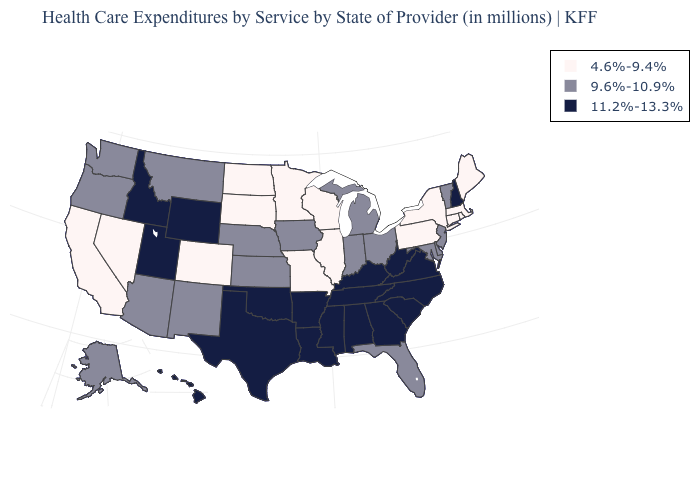Does West Virginia have the lowest value in the USA?
Be succinct. No. What is the value of Michigan?
Give a very brief answer. 9.6%-10.9%. Name the states that have a value in the range 4.6%-9.4%?
Keep it brief. California, Colorado, Connecticut, Illinois, Maine, Massachusetts, Minnesota, Missouri, Nevada, New York, North Dakota, Pennsylvania, Rhode Island, South Dakota, Wisconsin. Does Wyoming have the same value as South Carolina?
Answer briefly. Yes. Which states have the highest value in the USA?
Be succinct. Alabama, Arkansas, Georgia, Hawaii, Idaho, Kentucky, Louisiana, Mississippi, New Hampshire, North Carolina, Oklahoma, South Carolina, Tennessee, Texas, Utah, Virginia, West Virginia, Wyoming. Which states have the lowest value in the Northeast?
Write a very short answer. Connecticut, Maine, Massachusetts, New York, Pennsylvania, Rhode Island. Among the states that border Illinois , which have the highest value?
Quick response, please. Kentucky. What is the value of Delaware?
Short answer required. 9.6%-10.9%. Among the states that border Kentucky , which have the highest value?
Answer briefly. Tennessee, Virginia, West Virginia. Which states have the highest value in the USA?
Answer briefly. Alabama, Arkansas, Georgia, Hawaii, Idaho, Kentucky, Louisiana, Mississippi, New Hampshire, North Carolina, Oklahoma, South Carolina, Tennessee, Texas, Utah, Virginia, West Virginia, Wyoming. What is the highest value in the USA?
Answer briefly. 11.2%-13.3%. What is the value of Maine?
Quick response, please. 4.6%-9.4%. What is the highest value in the USA?
Be succinct. 11.2%-13.3%. What is the value of Minnesota?
Be succinct. 4.6%-9.4%. Does Ohio have the same value as Vermont?
Concise answer only. Yes. 